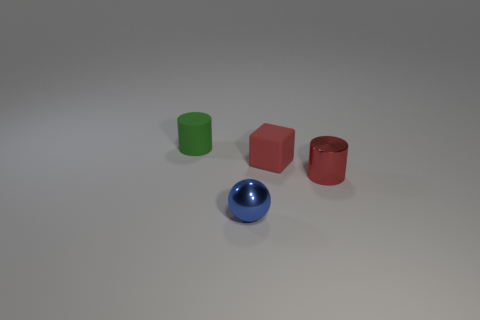What number of things are cylinders or blocks? In the image, there are a total of four objects present, among which three items fit the description of being either cylinders or blocks. Specifically, there are two cylinders and one block. 